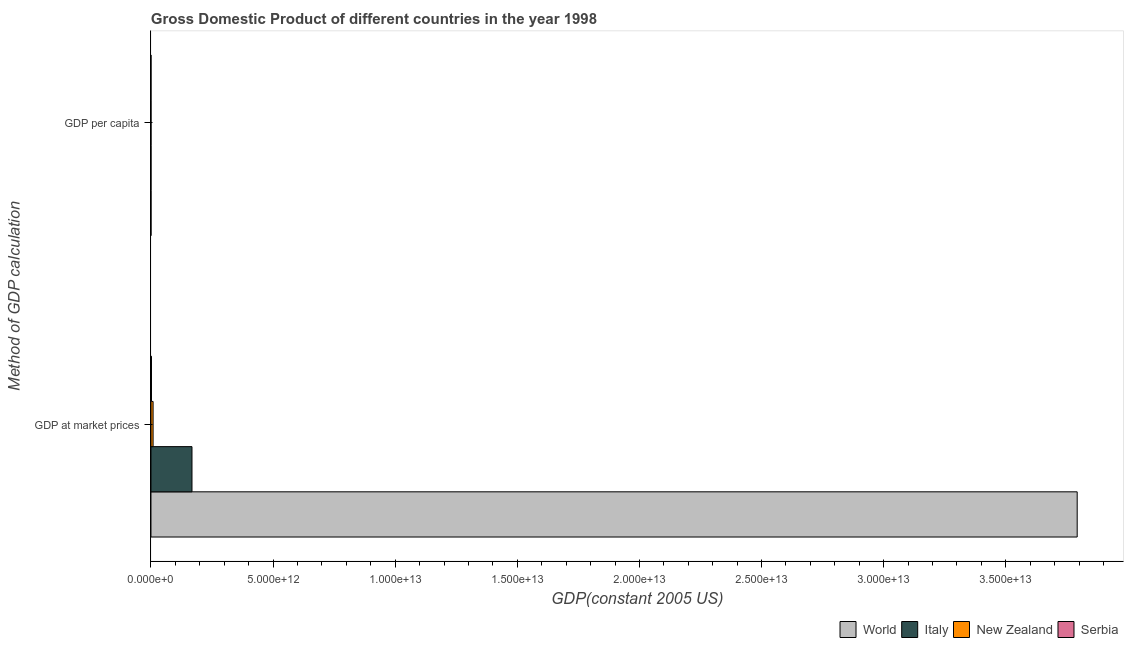How many groups of bars are there?
Provide a succinct answer. 2. Are the number of bars per tick equal to the number of legend labels?
Offer a very short reply. Yes. How many bars are there on the 2nd tick from the bottom?
Make the answer very short. 4. What is the label of the 2nd group of bars from the top?
Your response must be concise. GDP at market prices. What is the gdp per capita in World?
Offer a very short reply. 6369.29. Across all countries, what is the maximum gdp per capita?
Your answer should be compact. 2.95e+04. Across all countries, what is the minimum gdp at market prices?
Ensure brevity in your answer.  2.05e+1. In which country was the gdp per capita minimum?
Your answer should be compact. Serbia. What is the total gdp at market prices in the graph?
Provide a short and direct response. 3.97e+13. What is the difference between the gdp per capita in World and that in Italy?
Your response must be concise. -2.31e+04. What is the difference between the gdp at market prices in Serbia and the gdp per capita in World?
Provide a succinct answer. 2.05e+1. What is the average gdp at market prices per country?
Offer a very short reply. 9.93e+12. What is the difference between the gdp per capita and gdp at market prices in New Zealand?
Your response must be concise. -8.71e+1. In how many countries, is the gdp per capita greater than 2000000000000 US$?
Your answer should be compact. 0. What is the ratio of the gdp per capita in Serbia to that in New Zealand?
Give a very brief answer. 0.12. Is the gdp per capita in Serbia less than that in New Zealand?
Ensure brevity in your answer.  Yes. What does the 4th bar from the top in GDP per capita represents?
Give a very brief answer. World. What does the 4th bar from the bottom in GDP at market prices represents?
Your answer should be compact. Serbia. Are all the bars in the graph horizontal?
Provide a short and direct response. Yes. What is the difference between two consecutive major ticks on the X-axis?
Your response must be concise. 5.00e+12. How are the legend labels stacked?
Give a very brief answer. Horizontal. What is the title of the graph?
Offer a terse response. Gross Domestic Product of different countries in the year 1998. What is the label or title of the X-axis?
Offer a very short reply. GDP(constant 2005 US). What is the label or title of the Y-axis?
Offer a terse response. Method of GDP calculation. What is the GDP(constant 2005 US) of World in GDP at market prices?
Provide a short and direct response. 3.79e+13. What is the GDP(constant 2005 US) of Italy in GDP at market prices?
Give a very brief answer. 1.68e+12. What is the GDP(constant 2005 US) of New Zealand in GDP at market prices?
Ensure brevity in your answer.  8.71e+1. What is the GDP(constant 2005 US) of Serbia in GDP at market prices?
Give a very brief answer. 2.05e+1. What is the GDP(constant 2005 US) in World in GDP per capita?
Give a very brief answer. 6369.29. What is the GDP(constant 2005 US) in Italy in GDP per capita?
Provide a short and direct response. 2.95e+04. What is the GDP(constant 2005 US) in New Zealand in GDP per capita?
Your answer should be very brief. 2.28e+04. What is the GDP(constant 2005 US) of Serbia in GDP per capita?
Keep it short and to the point. 2711.28. Across all Method of GDP calculation, what is the maximum GDP(constant 2005 US) of World?
Your answer should be compact. 3.79e+13. Across all Method of GDP calculation, what is the maximum GDP(constant 2005 US) of Italy?
Provide a short and direct response. 1.68e+12. Across all Method of GDP calculation, what is the maximum GDP(constant 2005 US) of New Zealand?
Your answer should be very brief. 8.71e+1. Across all Method of GDP calculation, what is the maximum GDP(constant 2005 US) in Serbia?
Keep it short and to the point. 2.05e+1. Across all Method of GDP calculation, what is the minimum GDP(constant 2005 US) in World?
Make the answer very short. 6369.29. Across all Method of GDP calculation, what is the minimum GDP(constant 2005 US) in Italy?
Your answer should be compact. 2.95e+04. Across all Method of GDP calculation, what is the minimum GDP(constant 2005 US) in New Zealand?
Your answer should be compact. 2.28e+04. Across all Method of GDP calculation, what is the minimum GDP(constant 2005 US) in Serbia?
Keep it short and to the point. 2711.28. What is the total GDP(constant 2005 US) of World in the graph?
Keep it short and to the point. 3.79e+13. What is the total GDP(constant 2005 US) in Italy in the graph?
Provide a succinct answer. 1.68e+12. What is the total GDP(constant 2005 US) of New Zealand in the graph?
Your answer should be very brief. 8.71e+1. What is the total GDP(constant 2005 US) in Serbia in the graph?
Offer a very short reply. 2.05e+1. What is the difference between the GDP(constant 2005 US) in World in GDP at market prices and that in GDP per capita?
Provide a short and direct response. 3.79e+13. What is the difference between the GDP(constant 2005 US) of Italy in GDP at market prices and that in GDP per capita?
Make the answer very short. 1.68e+12. What is the difference between the GDP(constant 2005 US) in New Zealand in GDP at market prices and that in GDP per capita?
Offer a terse response. 8.71e+1. What is the difference between the GDP(constant 2005 US) in Serbia in GDP at market prices and that in GDP per capita?
Offer a very short reply. 2.05e+1. What is the difference between the GDP(constant 2005 US) of World in GDP at market prices and the GDP(constant 2005 US) of Italy in GDP per capita?
Your answer should be very brief. 3.79e+13. What is the difference between the GDP(constant 2005 US) in World in GDP at market prices and the GDP(constant 2005 US) in New Zealand in GDP per capita?
Your response must be concise. 3.79e+13. What is the difference between the GDP(constant 2005 US) in World in GDP at market prices and the GDP(constant 2005 US) in Serbia in GDP per capita?
Give a very brief answer. 3.79e+13. What is the difference between the GDP(constant 2005 US) in Italy in GDP at market prices and the GDP(constant 2005 US) in New Zealand in GDP per capita?
Give a very brief answer. 1.68e+12. What is the difference between the GDP(constant 2005 US) of Italy in GDP at market prices and the GDP(constant 2005 US) of Serbia in GDP per capita?
Your answer should be compact. 1.68e+12. What is the difference between the GDP(constant 2005 US) of New Zealand in GDP at market prices and the GDP(constant 2005 US) of Serbia in GDP per capita?
Ensure brevity in your answer.  8.71e+1. What is the average GDP(constant 2005 US) of World per Method of GDP calculation?
Offer a terse response. 1.90e+13. What is the average GDP(constant 2005 US) in Italy per Method of GDP calculation?
Keep it short and to the point. 8.40e+11. What is the average GDP(constant 2005 US) in New Zealand per Method of GDP calculation?
Offer a very short reply. 4.35e+1. What is the average GDP(constant 2005 US) in Serbia per Method of GDP calculation?
Keep it short and to the point. 1.03e+1. What is the difference between the GDP(constant 2005 US) of World and GDP(constant 2005 US) of Italy in GDP at market prices?
Offer a very short reply. 3.62e+13. What is the difference between the GDP(constant 2005 US) of World and GDP(constant 2005 US) of New Zealand in GDP at market prices?
Your response must be concise. 3.78e+13. What is the difference between the GDP(constant 2005 US) of World and GDP(constant 2005 US) of Serbia in GDP at market prices?
Your answer should be very brief. 3.79e+13. What is the difference between the GDP(constant 2005 US) of Italy and GDP(constant 2005 US) of New Zealand in GDP at market prices?
Provide a short and direct response. 1.59e+12. What is the difference between the GDP(constant 2005 US) in Italy and GDP(constant 2005 US) in Serbia in GDP at market prices?
Provide a succinct answer. 1.66e+12. What is the difference between the GDP(constant 2005 US) of New Zealand and GDP(constant 2005 US) of Serbia in GDP at market prices?
Your answer should be compact. 6.66e+1. What is the difference between the GDP(constant 2005 US) of World and GDP(constant 2005 US) of Italy in GDP per capita?
Provide a succinct answer. -2.31e+04. What is the difference between the GDP(constant 2005 US) in World and GDP(constant 2005 US) in New Zealand in GDP per capita?
Provide a succinct answer. -1.65e+04. What is the difference between the GDP(constant 2005 US) of World and GDP(constant 2005 US) of Serbia in GDP per capita?
Your answer should be compact. 3658.01. What is the difference between the GDP(constant 2005 US) in Italy and GDP(constant 2005 US) in New Zealand in GDP per capita?
Offer a very short reply. 6684.5. What is the difference between the GDP(constant 2005 US) of Italy and GDP(constant 2005 US) of Serbia in GDP per capita?
Keep it short and to the point. 2.68e+04. What is the difference between the GDP(constant 2005 US) of New Zealand and GDP(constant 2005 US) of Serbia in GDP per capita?
Your answer should be compact. 2.01e+04. What is the ratio of the GDP(constant 2005 US) of World in GDP at market prices to that in GDP per capita?
Provide a succinct answer. 5.95e+09. What is the ratio of the GDP(constant 2005 US) in Italy in GDP at market prices to that in GDP per capita?
Offer a very short reply. 5.69e+07. What is the ratio of the GDP(constant 2005 US) in New Zealand in GDP at market prices to that in GDP per capita?
Keep it short and to the point. 3.82e+06. What is the ratio of the GDP(constant 2005 US) in Serbia in GDP at market prices to that in GDP per capita?
Provide a short and direct response. 7.57e+06. What is the difference between the highest and the second highest GDP(constant 2005 US) in World?
Provide a succinct answer. 3.79e+13. What is the difference between the highest and the second highest GDP(constant 2005 US) in Italy?
Offer a very short reply. 1.68e+12. What is the difference between the highest and the second highest GDP(constant 2005 US) in New Zealand?
Make the answer very short. 8.71e+1. What is the difference between the highest and the second highest GDP(constant 2005 US) in Serbia?
Make the answer very short. 2.05e+1. What is the difference between the highest and the lowest GDP(constant 2005 US) in World?
Ensure brevity in your answer.  3.79e+13. What is the difference between the highest and the lowest GDP(constant 2005 US) of Italy?
Provide a succinct answer. 1.68e+12. What is the difference between the highest and the lowest GDP(constant 2005 US) in New Zealand?
Keep it short and to the point. 8.71e+1. What is the difference between the highest and the lowest GDP(constant 2005 US) in Serbia?
Your answer should be compact. 2.05e+1. 